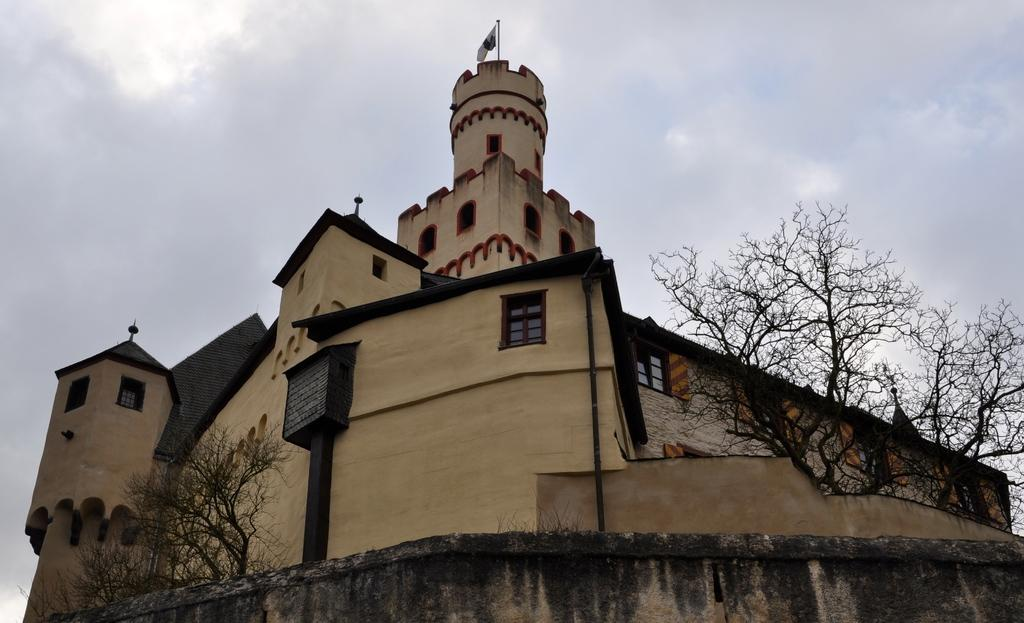What type of structure is in the image? There is a castle in the image. What other elements can be seen in the image besides the castle? There are trees in the image. What is visible in the background of the image? The sky is visible in the background of the image. Can you describe the sky in the image? Clouds are present in the sky. What type of desk can be seen in the image? There is no desk present in the image. Can you describe the throat of the snail in the image? There is no snail present in the image, so it is not possible to describe its throat. 